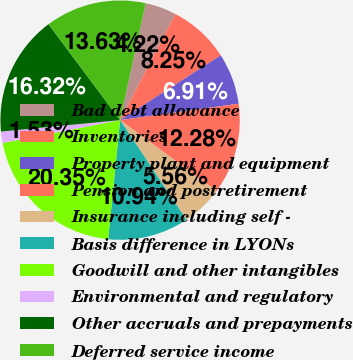<chart> <loc_0><loc_0><loc_500><loc_500><pie_chart><fcel>Bad debt allowance<fcel>Inventories<fcel>Property plant and equipment<fcel>Pension and postretirement<fcel>Insurance including self -<fcel>Basis difference in LYONs<fcel>Goodwill and other intangibles<fcel>Environmental and regulatory<fcel>Other accruals and prepayments<fcel>Deferred service income<nl><fcel>4.22%<fcel>8.25%<fcel>6.91%<fcel>12.28%<fcel>5.56%<fcel>10.94%<fcel>20.35%<fcel>1.53%<fcel>16.32%<fcel>13.63%<nl></chart> 